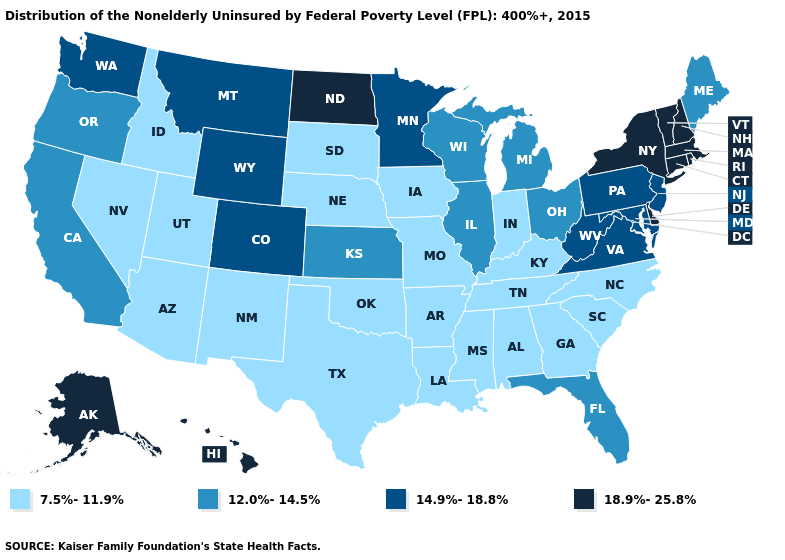What is the highest value in the MidWest ?
Quick response, please. 18.9%-25.8%. Is the legend a continuous bar?
Be succinct. No. Which states have the lowest value in the South?
Short answer required. Alabama, Arkansas, Georgia, Kentucky, Louisiana, Mississippi, North Carolina, Oklahoma, South Carolina, Tennessee, Texas. What is the highest value in the West ?
Short answer required. 18.9%-25.8%. What is the lowest value in the USA?
Be succinct. 7.5%-11.9%. Name the states that have a value in the range 18.9%-25.8%?
Keep it brief. Alaska, Connecticut, Delaware, Hawaii, Massachusetts, New Hampshire, New York, North Dakota, Rhode Island, Vermont. What is the highest value in the USA?
Keep it brief. 18.9%-25.8%. What is the lowest value in the USA?
Write a very short answer. 7.5%-11.9%. Among the states that border Michigan , does Ohio have the lowest value?
Quick response, please. No. Does the first symbol in the legend represent the smallest category?
Be succinct. Yes. Name the states that have a value in the range 14.9%-18.8%?
Be succinct. Colorado, Maryland, Minnesota, Montana, New Jersey, Pennsylvania, Virginia, Washington, West Virginia, Wyoming. Name the states that have a value in the range 12.0%-14.5%?
Short answer required. California, Florida, Illinois, Kansas, Maine, Michigan, Ohio, Oregon, Wisconsin. Does the map have missing data?
Short answer required. No. What is the highest value in the South ?
Quick response, please. 18.9%-25.8%. 